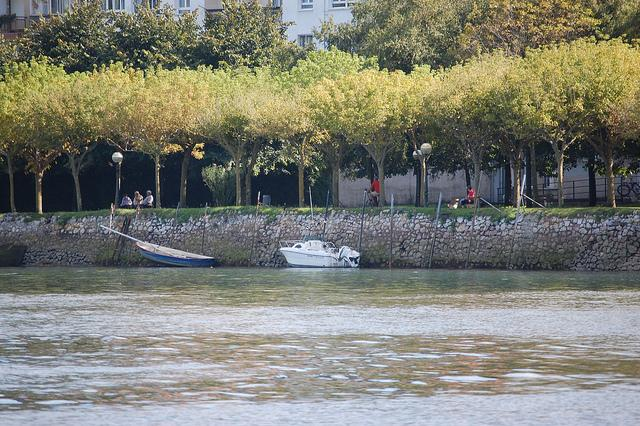What is the black rectangular object in front of the blue boat? Please explain your reasoning. ladder. This object has rungs. 